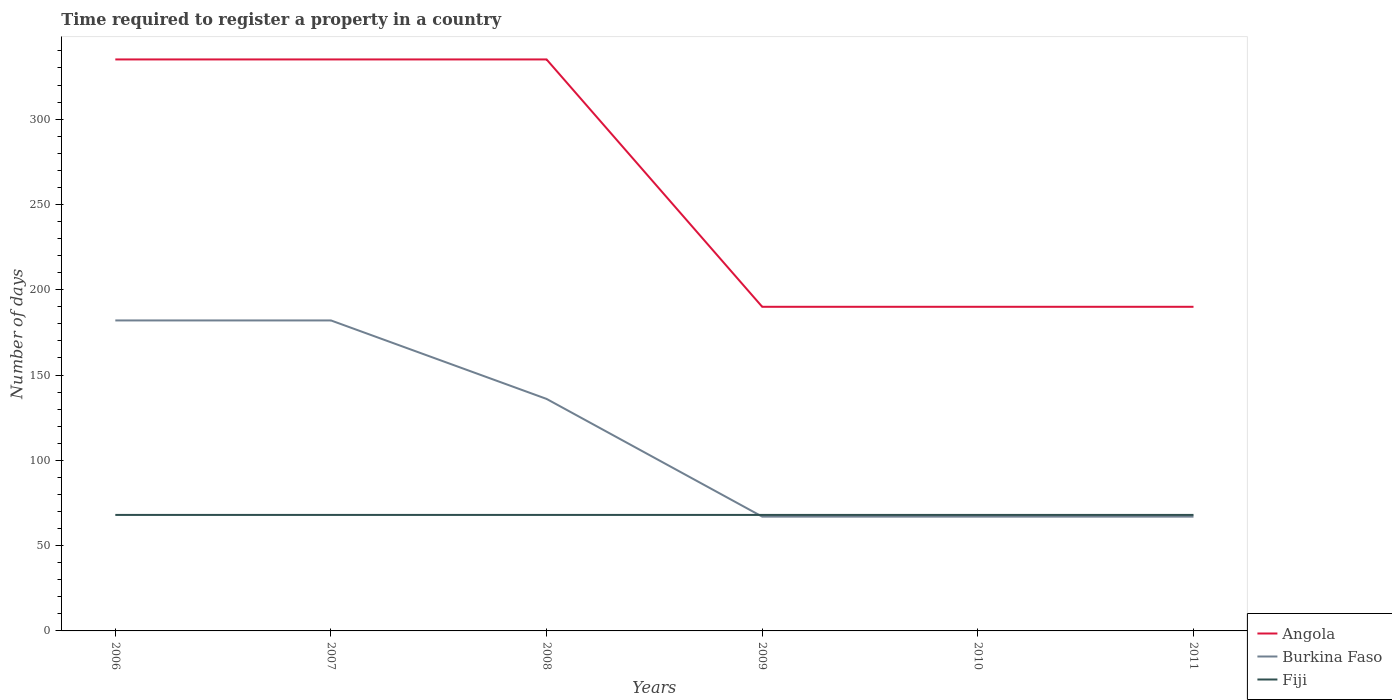How many different coloured lines are there?
Offer a terse response. 3. Across all years, what is the maximum number of days required to register a property in Burkina Faso?
Provide a succinct answer. 67. What is the total number of days required to register a property in Burkina Faso in the graph?
Make the answer very short. 69. What is the difference between the highest and the lowest number of days required to register a property in Angola?
Offer a terse response. 3. Is the number of days required to register a property in Fiji strictly greater than the number of days required to register a property in Burkina Faso over the years?
Offer a terse response. No. How many lines are there?
Provide a succinct answer. 3. What is the difference between two consecutive major ticks on the Y-axis?
Ensure brevity in your answer.  50. Are the values on the major ticks of Y-axis written in scientific E-notation?
Keep it short and to the point. No. Where does the legend appear in the graph?
Your answer should be very brief. Bottom right. How many legend labels are there?
Provide a short and direct response. 3. How are the legend labels stacked?
Ensure brevity in your answer.  Vertical. What is the title of the graph?
Offer a very short reply. Time required to register a property in a country. What is the label or title of the X-axis?
Your response must be concise. Years. What is the label or title of the Y-axis?
Provide a succinct answer. Number of days. What is the Number of days in Angola in 2006?
Ensure brevity in your answer.  335. What is the Number of days in Burkina Faso in 2006?
Provide a succinct answer. 182. What is the Number of days in Angola in 2007?
Provide a succinct answer. 335. What is the Number of days in Burkina Faso in 2007?
Make the answer very short. 182. What is the Number of days in Fiji in 2007?
Keep it short and to the point. 68. What is the Number of days of Angola in 2008?
Ensure brevity in your answer.  335. What is the Number of days of Burkina Faso in 2008?
Your answer should be very brief. 136. What is the Number of days in Angola in 2009?
Keep it short and to the point. 190. What is the Number of days of Fiji in 2009?
Provide a short and direct response. 68. What is the Number of days in Angola in 2010?
Your response must be concise. 190. What is the Number of days of Burkina Faso in 2010?
Offer a very short reply. 67. What is the Number of days of Angola in 2011?
Offer a terse response. 190. What is the Number of days of Fiji in 2011?
Ensure brevity in your answer.  68. Across all years, what is the maximum Number of days of Angola?
Provide a short and direct response. 335. Across all years, what is the maximum Number of days in Burkina Faso?
Provide a succinct answer. 182. Across all years, what is the maximum Number of days in Fiji?
Provide a short and direct response. 68. Across all years, what is the minimum Number of days in Angola?
Offer a very short reply. 190. Across all years, what is the minimum Number of days in Fiji?
Offer a terse response. 68. What is the total Number of days in Angola in the graph?
Your answer should be compact. 1575. What is the total Number of days in Burkina Faso in the graph?
Your answer should be compact. 701. What is the total Number of days in Fiji in the graph?
Your response must be concise. 408. What is the difference between the Number of days of Angola in 2006 and that in 2007?
Your response must be concise. 0. What is the difference between the Number of days in Angola in 2006 and that in 2008?
Your answer should be compact. 0. What is the difference between the Number of days of Burkina Faso in 2006 and that in 2008?
Keep it short and to the point. 46. What is the difference between the Number of days of Angola in 2006 and that in 2009?
Your answer should be compact. 145. What is the difference between the Number of days of Burkina Faso in 2006 and that in 2009?
Make the answer very short. 115. What is the difference between the Number of days in Angola in 2006 and that in 2010?
Your answer should be compact. 145. What is the difference between the Number of days of Burkina Faso in 2006 and that in 2010?
Give a very brief answer. 115. What is the difference between the Number of days in Angola in 2006 and that in 2011?
Make the answer very short. 145. What is the difference between the Number of days in Burkina Faso in 2006 and that in 2011?
Ensure brevity in your answer.  115. What is the difference between the Number of days in Angola in 2007 and that in 2008?
Provide a succinct answer. 0. What is the difference between the Number of days in Angola in 2007 and that in 2009?
Your answer should be compact. 145. What is the difference between the Number of days in Burkina Faso in 2007 and that in 2009?
Offer a very short reply. 115. What is the difference between the Number of days in Angola in 2007 and that in 2010?
Provide a short and direct response. 145. What is the difference between the Number of days of Burkina Faso in 2007 and that in 2010?
Your answer should be compact. 115. What is the difference between the Number of days in Angola in 2007 and that in 2011?
Your answer should be compact. 145. What is the difference between the Number of days in Burkina Faso in 2007 and that in 2011?
Your answer should be very brief. 115. What is the difference between the Number of days in Fiji in 2007 and that in 2011?
Your response must be concise. 0. What is the difference between the Number of days in Angola in 2008 and that in 2009?
Your answer should be very brief. 145. What is the difference between the Number of days in Burkina Faso in 2008 and that in 2009?
Your answer should be very brief. 69. What is the difference between the Number of days of Angola in 2008 and that in 2010?
Your response must be concise. 145. What is the difference between the Number of days in Fiji in 2008 and that in 2010?
Ensure brevity in your answer.  0. What is the difference between the Number of days of Angola in 2008 and that in 2011?
Keep it short and to the point. 145. What is the difference between the Number of days of Fiji in 2009 and that in 2010?
Your answer should be very brief. 0. What is the difference between the Number of days of Angola in 2010 and that in 2011?
Ensure brevity in your answer.  0. What is the difference between the Number of days of Burkina Faso in 2010 and that in 2011?
Offer a very short reply. 0. What is the difference between the Number of days in Angola in 2006 and the Number of days in Burkina Faso in 2007?
Provide a short and direct response. 153. What is the difference between the Number of days in Angola in 2006 and the Number of days in Fiji in 2007?
Your answer should be compact. 267. What is the difference between the Number of days of Burkina Faso in 2006 and the Number of days of Fiji in 2007?
Give a very brief answer. 114. What is the difference between the Number of days of Angola in 2006 and the Number of days of Burkina Faso in 2008?
Make the answer very short. 199. What is the difference between the Number of days in Angola in 2006 and the Number of days in Fiji in 2008?
Give a very brief answer. 267. What is the difference between the Number of days in Burkina Faso in 2006 and the Number of days in Fiji in 2008?
Offer a very short reply. 114. What is the difference between the Number of days of Angola in 2006 and the Number of days of Burkina Faso in 2009?
Your answer should be compact. 268. What is the difference between the Number of days of Angola in 2006 and the Number of days of Fiji in 2009?
Keep it short and to the point. 267. What is the difference between the Number of days in Burkina Faso in 2006 and the Number of days in Fiji in 2009?
Provide a succinct answer. 114. What is the difference between the Number of days in Angola in 2006 and the Number of days in Burkina Faso in 2010?
Offer a very short reply. 268. What is the difference between the Number of days in Angola in 2006 and the Number of days in Fiji in 2010?
Offer a very short reply. 267. What is the difference between the Number of days in Burkina Faso in 2006 and the Number of days in Fiji in 2010?
Offer a very short reply. 114. What is the difference between the Number of days in Angola in 2006 and the Number of days in Burkina Faso in 2011?
Provide a short and direct response. 268. What is the difference between the Number of days in Angola in 2006 and the Number of days in Fiji in 2011?
Offer a very short reply. 267. What is the difference between the Number of days of Burkina Faso in 2006 and the Number of days of Fiji in 2011?
Offer a terse response. 114. What is the difference between the Number of days of Angola in 2007 and the Number of days of Burkina Faso in 2008?
Your response must be concise. 199. What is the difference between the Number of days in Angola in 2007 and the Number of days in Fiji in 2008?
Your response must be concise. 267. What is the difference between the Number of days of Burkina Faso in 2007 and the Number of days of Fiji in 2008?
Offer a very short reply. 114. What is the difference between the Number of days in Angola in 2007 and the Number of days in Burkina Faso in 2009?
Keep it short and to the point. 268. What is the difference between the Number of days in Angola in 2007 and the Number of days in Fiji in 2009?
Ensure brevity in your answer.  267. What is the difference between the Number of days in Burkina Faso in 2007 and the Number of days in Fiji in 2009?
Offer a terse response. 114. What is the difference between the Number of days of Angola in 2007 and the Number of days of Burkina Faso in 2010?
Ensure brevity in your answer.  268. What is the difference between the Number of days of Angola in 2007 and the Number of days of Fiji in 2010?
Ensure brevity in your answer.  267. What is the difference between the Number of days of Burkina Faso in 2007 and the Number of days of Fiji in 2010?
Ensure brevity in your answer.  114. What is the difference between the Number of days in Angola in 2007 and the Number of days in Burkina Faso in 2011?
Offer a very short reply. 268. What is the difference between the Number of days of Angola in 2007 and the Number of days of Fiji in 2011?
Ensure brevity in your answer.  267. What is the difference between the Number of days in Burkina Faso in 2007 and the Number of days in Fiji in 2011?
Your answer should be compact. 114. What is the difference between the Number of days of Angola in 2008 and the Number of days of Burkina Faso in 2009?
Provide a succinct answer. 268. What is the difference between the Number of days of Angola in 2008 and the Number of days of Fiji in 2009?
Keep it short and to the point. 267. What is the difference between the Number of days in Angola in 2008 and the Number of days in Burkina Faso in 2010?
Give a very brief answer. 268. What is the difference between the Number of days in Angola in 2008 and the Number of days in Fiji in 2010?
Offer a very short reply. 267. What is the difference between the Number of days of Angola in 2008 and the Number of days of Burkina Faso in 2011?
Your answer should be compact. 268. What is the difference between the Number of days in Angola in 2008 and the Number of days in Fiji in 2011?
Offer a very short reply. 267. What is the difference between the Number of days of Angola in 2009 and the Number of days of Burkina Faso in 2010?
Offer a terse response. 123. What is the difference between the Number of days in Angola in 2009 and the Number of days in Fiji in 2010?
Your answer should be very brief. 122. What is the difference between the Number of days of Burkina Faso in 2009 and the Number of days of Fiji in 2010?
Your response must be concise. -1. What is the difference between the Number of days in Angola in 2009 and the Number of days in Burkina Faso in 2011?
Offer a terse response. 123. What is the difference between the Number of days of Angola in 2009 and the Number of days of Fiji in 2011?
Your answer should be very brief. 122. What is the difference between the Number of days of Burkina Faso in 2009 and the Number of days of Fiji in 2011?
Make the answer very short. -1. What is the difference between the Number of days in Angola in 2010 and the Number of days in Burkina Faso in 2011?
Offer a very short reply. 123. What is the difference between the Number of days of Angola in 2010 and the Number of days of Fiji in 2011?
Provide a short and direct response. 122. What is the average Number of days of Angola per year?
Your answer should be very brief. 262.5. What is the average Number of days of Burkina Faso per year?
Offer a very short reply. 116.83. In the year 2006, what is the difference between the Number of days of Angola and Number of days of Burkina Faso?
Provide a short and direct response. 153. In the year 2006, what is the difference between the Number of days in Angola and Number of days in Fiji?
Provide a short and direct response. 267. In the year 2006, what is the difference between the Number of days of Burkina Faso and Number of days of Fiji?
Give a very brief answer. 114. In the year 2007, what is the difference between the Number of days of Angola and Number of days of Burkina Faso?
Offer a terse response. 153. In the year 2007, what is the difference between the Number of days of Angola and Number of days of Fiji?
Your response must be concise. 267. In the year 2007, what is the difference between the Number of days of Burkina Faso and Number of days of Fiji?
Ensure brevity in your answer.  114. In the year 2008, what is the difference between the Number of days in Angola and Number of days in Burkina Faso?
Give a very brief answer. 199. In the year 2008, what is the difference between the Number of days of Angola and Number of days of Fiji?
Ensure brevity in your answer.  267. In the year 2008, what is the difference between the Number of days in Burkina Faso and Number of days in Fiji?
Your answer should be compact. 68. In the year 2009, what is the difference between the Number of days of Angola and Number of days of Burkina Faso?
Make the answer very short. 123. In the year 2009, what is the difference between the Number of days in Angola and Number of days in Fiji?
Offer a terse response. 122. In the year 2010, what is the difference between the Number of days of Angola and Number of days of Burkina Faso?
Ensure brevity in your answer.  123. In the year 2010, what is the difference between the Number of days in Angola and Number of days in Fiji?
Your answer should be very brief. 122. In the year 2010, what is the difference between the Number of days of Burkina Faso and Number of days of Fiji?
Offer a very short reply. -1. In the year 2011, what is the difference between the Number of days of Angola and Number of days of Burkina Faso?
Offer a very short reply. 123. In the year 2011, what is the difference between the Number of days of Angola and Number of days of Fiji?
Your answer should be compact. 122. What is the ratio of the Number of days in Angola in 2006 to that in 2007?
Your response must be concise. 1. What is the ratio of the Number of days of Burkina Faso in 2006 to that in 2008?
Ensure brevity in your answer.  1.34. What is the ratio of the Number of days in Fiji in 2006 to that in 2008?
Give a very brief answer. 1. What is the ratio of the Number of days of Angola in 2006 to that in 2009?
Offer a terse response. 1.76. What is the ratio of the Number of days in Burkina Faso in 2006 to that in 2009?
Your response must be concise. 2.72. What is the ratio of the Number of days in Angola in 2006 to that in 2010?
Ensure brevity in your answer.  1.76. What is the ratio of the Number of days in Burkina Faso in 2006 to that in 2010?
Give a very brief answer. 2.72. What is the ratio of the Number of days of Angola in 2006 to that in 2011?
Provide a short and direct response. 1.76. What is the ratio of the Number of days in Burkina Faso in 2006 to that in 2011?
Ensure brevity in your answer.  2.72. What is the ratio of the Number of days of Fiji in 2006 to that in 2011?
Your answer should be compact. 1. What is the ratio of the Number of days of Angola in 2007 to that in 2008?
Offer a terse response. 1. What is the ratio of the Number of days in Burkina Faso in 2007 to that in 2008?
Ensure brevity in your answer.  1.34. What is the ratio of the Number of days of Fiji in 2007 to that in 2008?
Offer a terse response. 1. What is the ratio of the Number of days of Angola in 2007 to that in 2009?
Your answer should be compact. 1.76. What is the ratio of the Number of days in Burkina Faso in 2007 to that in 2009?
Offer a terse response. 2.72. What is the ratio of the Number of days in Fiji in 2007 to that in 2009?
Provide a succinct answer. 1. What is the ratio of the Number of days in Angola in 2007 to that in 2010?
Provide a short and direct response. 1.76. What is the ratio of the Number of days in Burkina Faso in 2007 to that in 2010?
Ensure brevity in your answer.  2.72. What is the ratio of the Number of days in Angola in 2007 to that in 2011?
Offer a terse response. 1.76. What is the ratio of the Number of days in Burkina Faso in 2007 to that in 2011?
Offer a terse response. 2.72. What is the ratio of the Number of days in Angola in 2008 to that in 2009?
Ensure brevity in your answer.  1.76. What is the ratio of the Number of days of Burkina Faso in 2008 to that in 2009?
Your answer should be very brief. 2.03. What is the ratio of the Number of days of Fiji in 2008 to that in 2009?
Provide a short and direct response. 1. What is the ratio of the Number of days of Angola in 2008 to that in 2010?
Your response must be concise. 1.76. What is the ratio of the Number of days of Burkina Faso in 2008 to that in 2010?
Your answer should be very brief. 2.03. What is the ratio of the Number of days of Fiji in 2008 to that in 2010?
Your answer should be compact. 1. What is the ratio of the Number of days of Angola in 2008 to that in 2011?
Make the answer very short. 1.76. What is the ratio of the Number of days in Burkina Faso in 2008 to that in 2011?
Give a very brief answer. 2.03. What is the ratio of the Number of days of Fiji in 2008 to that in 2011?
Provide a short and direct response. 1. What is the ratio of the Number of days in Angola in 2009 to that in 2010?
Make the answer very short. 1. What is the ratio of the Number of days of Burkina Faso in 2009 to that in 2010?
Your answer should be compact. 1. What is the ratio of the Number of days of Fiji in 2009 to that in 2010?
Offer a very short reply. 1. What is the ratio of the Number of days in Angola in 2009 to that in 2011?
Ensure brevity in your answer.  1. What is the ratio of the Number of days in Burkina Faso in 2009 to that in 2011?
Provide a succinct answer. 1. What is the ratio of the Number of days in Angola in 2010 to that in 2011?
Provide a succinct answer. 1. What is the difference between the highest and the second highest Number of days in Burkina Faso?
Ensure brevity in your answer.  0. What is the difference between the highest and the lowest Number of days in Angola?
Your answer should be compact. 145. What is the difference between the highest and the lowest Number of days of Burkina Faso?
Your answer should be compact. 115. 